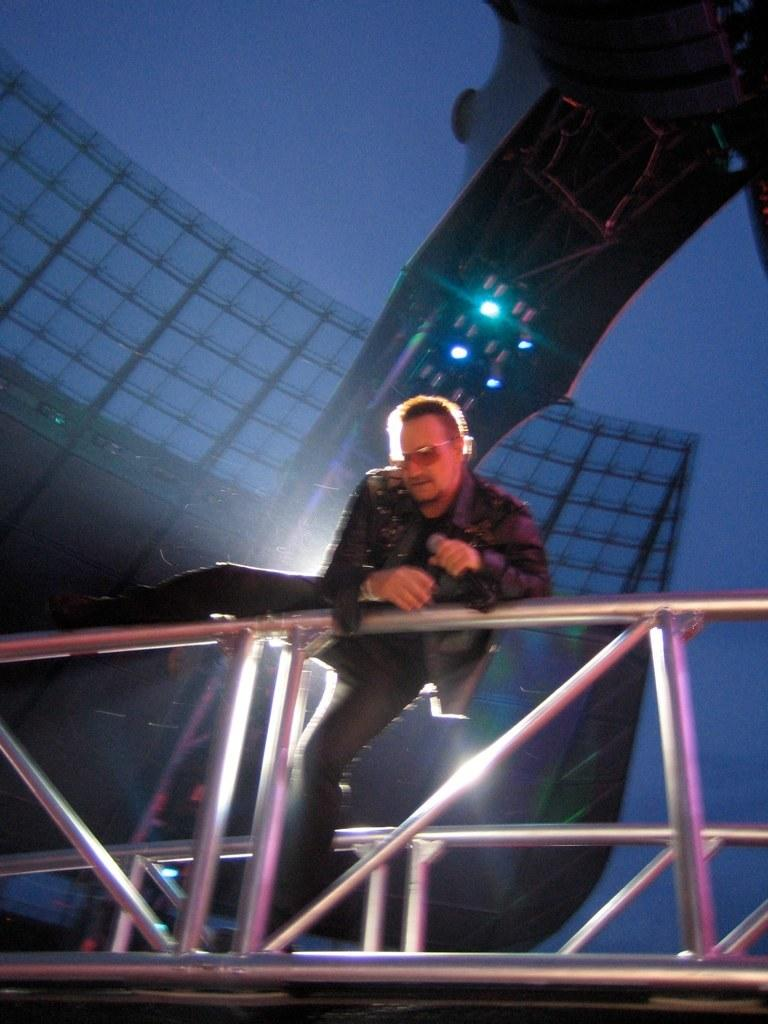What is the main subject in the center of the image? There is a man standing in the center of the image. What objects can be seen in the image besides the man? There are iron rods in the image. What can be seen in the background of the image? There is a building and an unspecified object in the background of the image. What else is visible in the image? There are lights visible in the image. What type of turkey can be seen swimming in the background of the image? There is no turkey or any aquatic animals present in the image; it features a man, iron rods, a building, an unspecified object, and lights. 